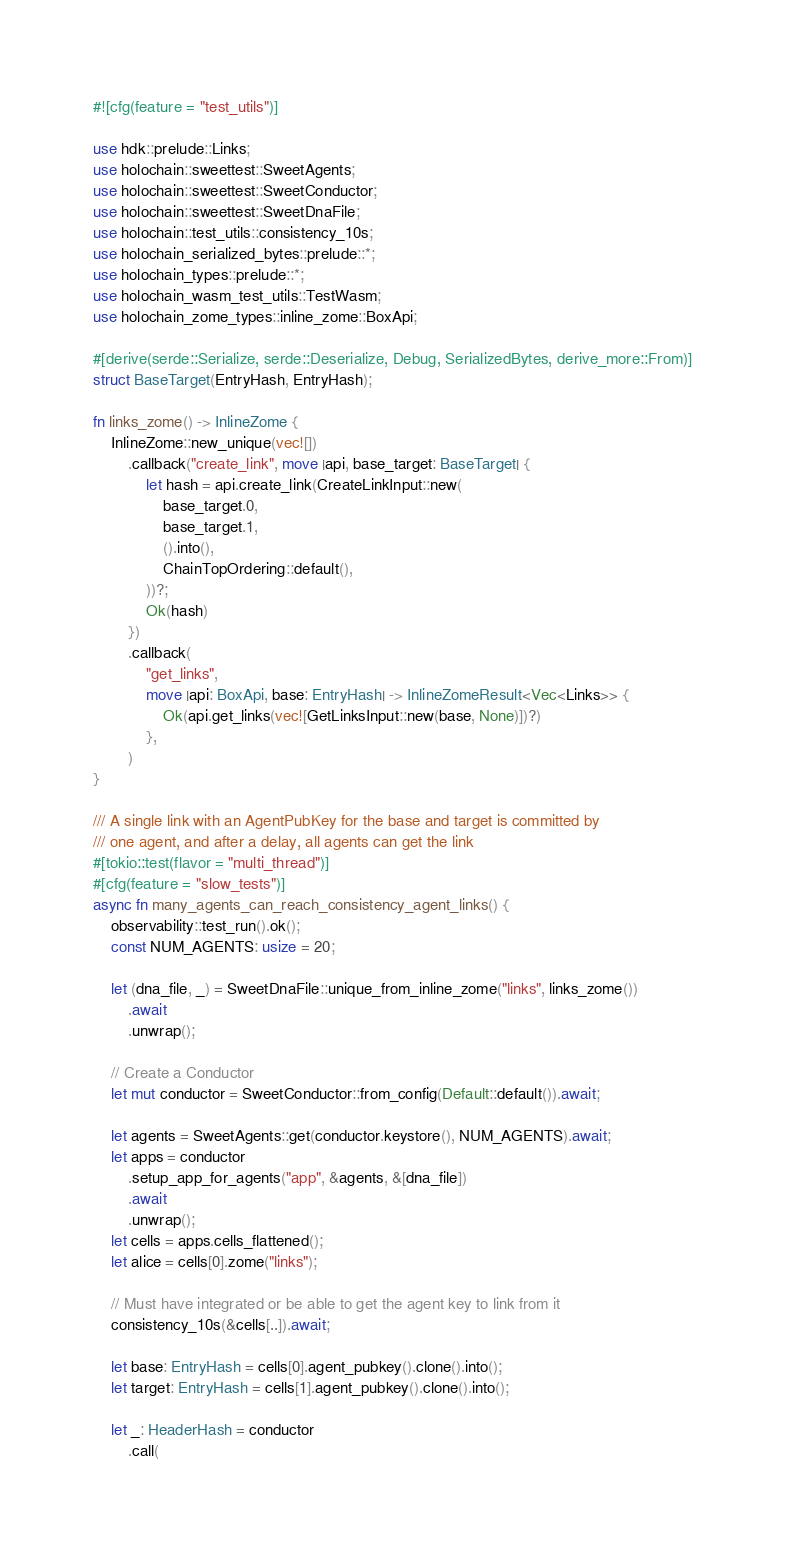Convert code to text. <code><loc_0><loc_0><loc_500><loc_500><_Rust_>#![cfg(feature = "test_utils")]

use hdk::prelude::Links;
use holochain::sweettest::SweetAgents;
use holochain::sweettest::SweetConductor;
use holochain::sweettest::SweetDnaFile;
use holochain::test_utils::consistency_10s;
use holochain_serialized_bytes::prelude::*;
use holochain_types::prelude::*;
use holochain_wasm_test_utils::TestWasm;
use holochain_zome_types::inline_zome::BoxApi;

#[derive(serde::Serialize, serde::Deserialize, Debug, SerializedBytes, derive_more::From)]
struct BaseTarget(EntryHash, EntryHash);

fn links_zome() -> InlineZome {
    InlineZome::new_unique(vec![])
        .callback("create_link", move |api, base_target: BaseTarget| {
            let hash = api.create_link(CreateLinkInput::new(
                base_target.0,
                base_target.1,
                ().into(),
                ChainTopOrdering::default(),
            ))?;
            Ok(hash)
        })
        .callback(
            "get_links",
            move |api: BoxApi, base: EntryHash| -> InlineZomeResult<Vec<Links>> {
                Ok(api.get_links(vec![GetLinksInput::new(base, None)])?)
            },
        )
}

/// A single link with an AgentPubKey for the base and target is committed by
/// one agent, and after a delay, all agents can get the link
#[tokio::test(flavor = "multi_thread")]
#[cfg(feature = "slow_tests")]
async fn many_agents_can_reach_consistency_agent_links() {
    observability::test_run().ok();
    const NUM_AGENTS: usize = 20;

    let (dna_file, _) = SweetDnaFile::unique_from_inline_zome("links", links_zome())
        .await
        .unwrap();

    // Create a Conductor
    let mut conductor = SweetConductor::from_config(Default::default()).await;

    let agents = SweetAgents::get(conductor.keystore(), NUM_AGENTS).await;
    let apps = conductor
        .setup_app_for_agents("app", &agents, &[dna_file])
        .await
        .unwrap();
    let cells = apps.cells_flattened();
    let alice = cells[0].zome("links");

    // Must have integrated or be able to get the agent key to link from it
    consistency_10s(&cells[..]).await;

    let base: EntryHash = cells[0].agent_pubkey().clone().into();
    let target: EntryHash = cells[1].agent_pubkey().clone().into();

    let _: HeaderHash = conductor
        .call(</code> 